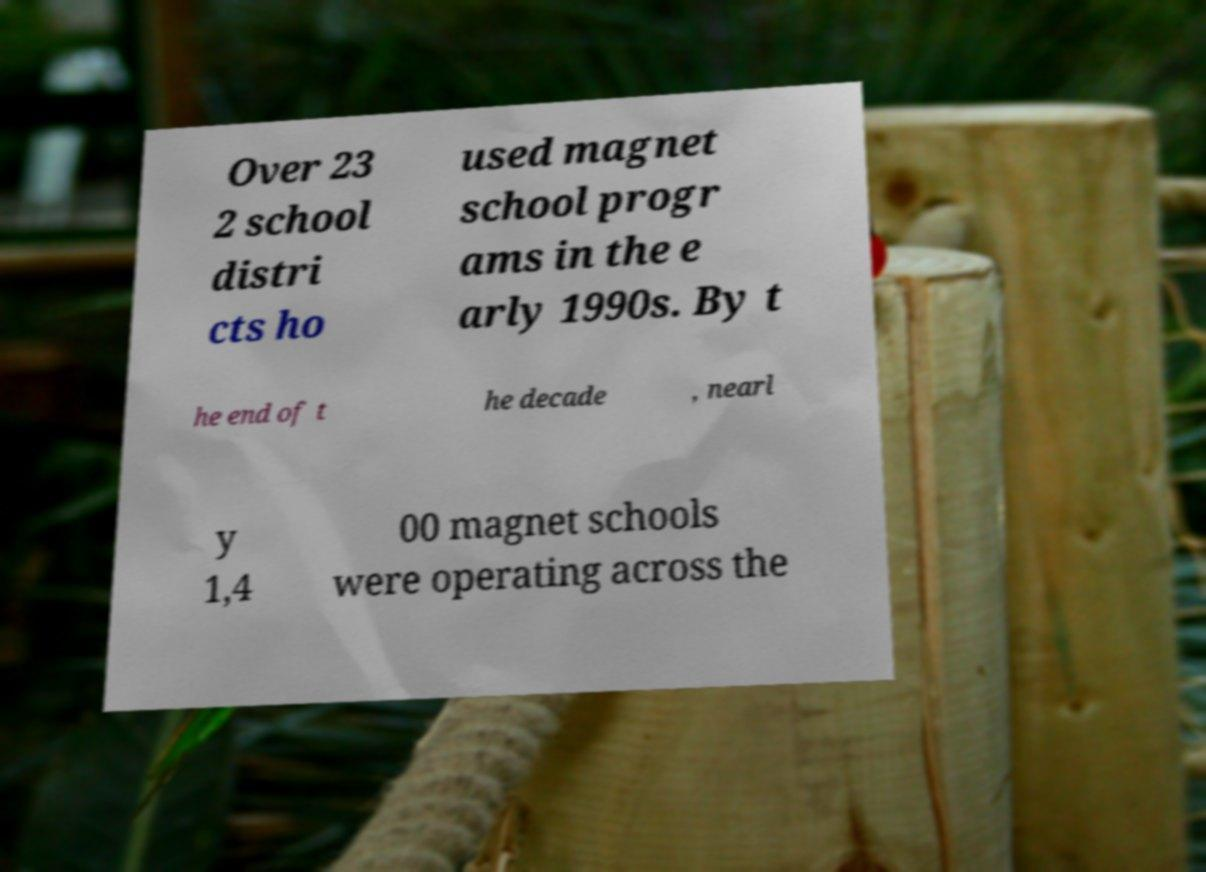Can you accurately transcribe the text from the provided image for me? Over 23 2 school distri cts ho used magnet school progr ams in the e arly 1990s. By t he end of t he decade , nearl y 1,4 00 magnet schools were operating across the 